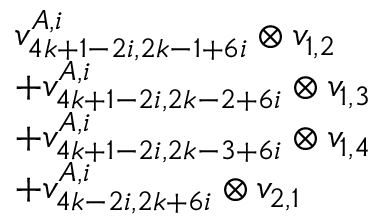<formula> <loc_0><loc_0><loc_500><loc_500>\begin{array} { r l } & { v _ { 4 k + 1 - 2 i , 2 k - 1 + 6 i } ^ { A , i } \otimes v _ { 1 , 2 } } \\ & { + v _ { 4 k + 1 - 2 i , 2 k - 2 + 6 i } ^ { A , i } \otimes v _ { 1 , 3 } } \\ & { + v _ { 4 k + 1 - 2 i , 2 k - 3 + 6 i } ^ { A , i } \otimes v _ { 1 , 4 } } \\ & { + v _ { 4 k - 2 i , 2 k + 6 i } ^ { A , i } \otimes v _ { 2 , 1 } } \end{array}</formula> 